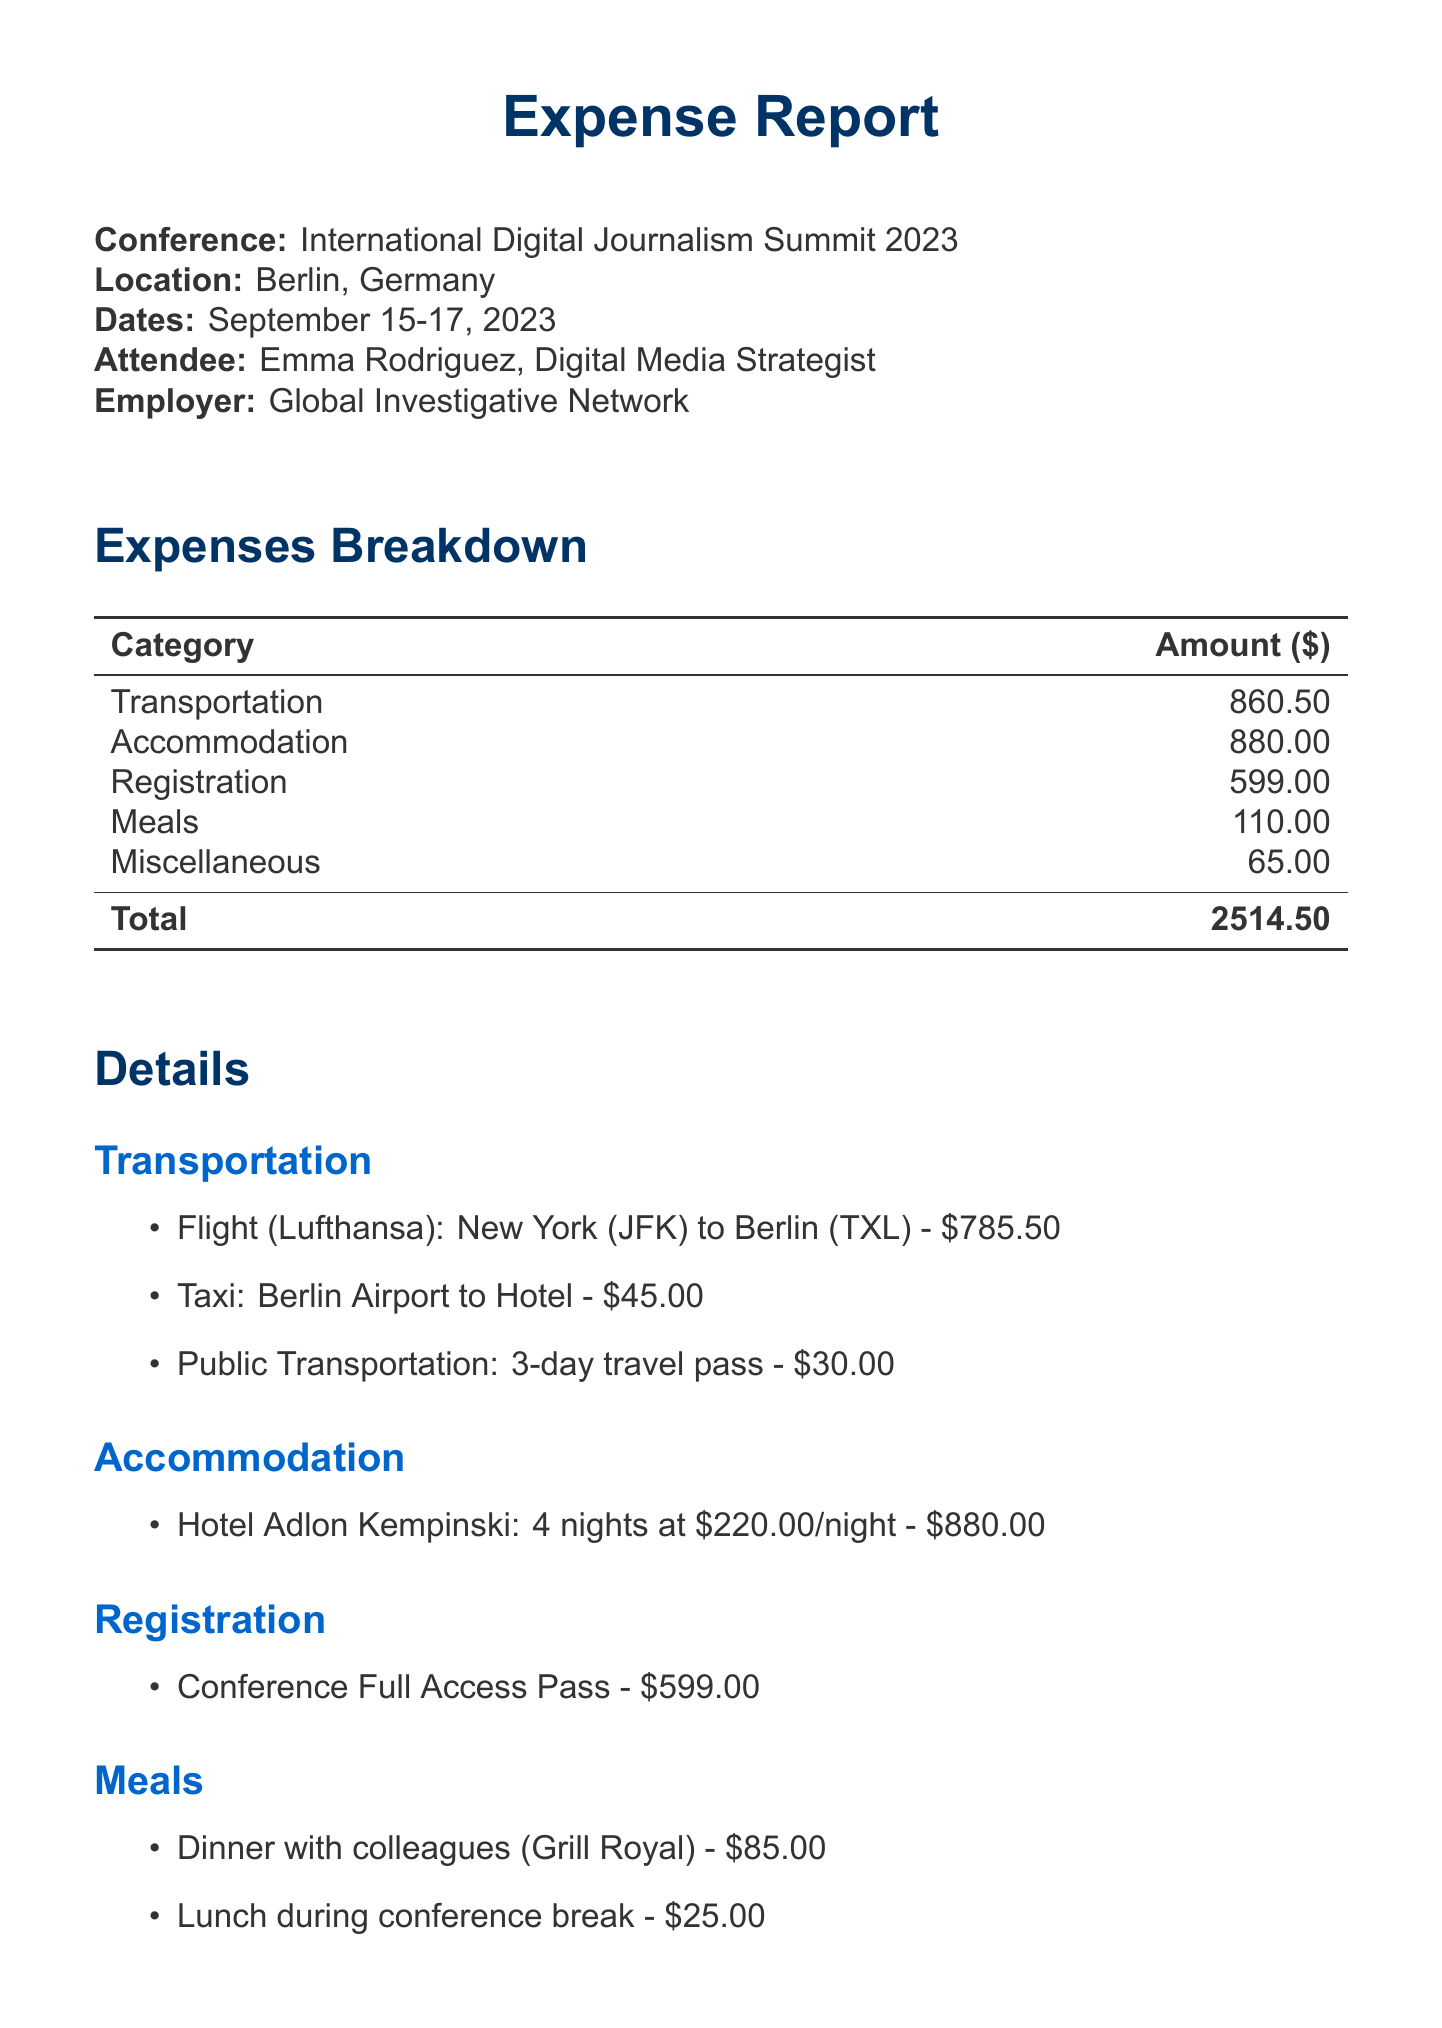What is the name of the conference? The name of the conference is explicitly stated in the document under "Conference", which is "International Digital Journalism Summit 2023".
Answer: International Digital Journalism Summit 2023 What is the total cost of accommodation? The total cost of accommodation is listed in the breakdown of expenses, which is $880.00 for 4 nights at $220.00 per night.
Answer: $880.00 Who provided the flight service? The document specifies the provider of the flight service as "Lufthansa".
Answer: Lufthansa What was the date of the flight from New York to Berlin? The date is included in the transportation section and is specified as "2023-09-14".
Answer: 2023-09-14 How much was spent on meals? The total spent on meals is detailed in the expenses breakdown, specifically listed as $110.00.
Answer: $110.00 What is the approval status of the expense report? The approval status is stated near the end of the document as "Pending".
Answer: Pending How many nights did Emma stay at the hotel? The document specifies the length of stay in the accommodation section as "4 nights".
Answer: 4 nights What is the cost of the conference registration? The cost for the conference registration is clearly mentioned as $599.00.
Answer: $599.00 Which restaurant did Emma dine at for dinner? The document lists the restaurant for dinner as "Grill Royal".
Answer: Grill Royal 